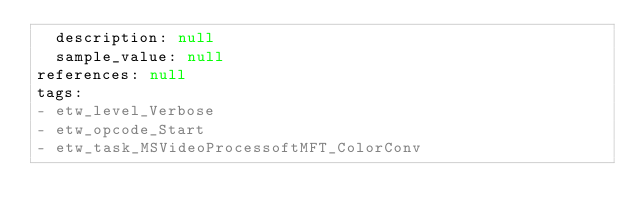Convert code to text. <code><loc_0><loc_0><loc_500><loc_500><_YAML_>  description: null
  sample_value: null
references: null
tags:
- etw_level_Verbose
- etw_opcode_Start
- etw_task_MSVideoProcessoftMFT_ColorConv
</code> 